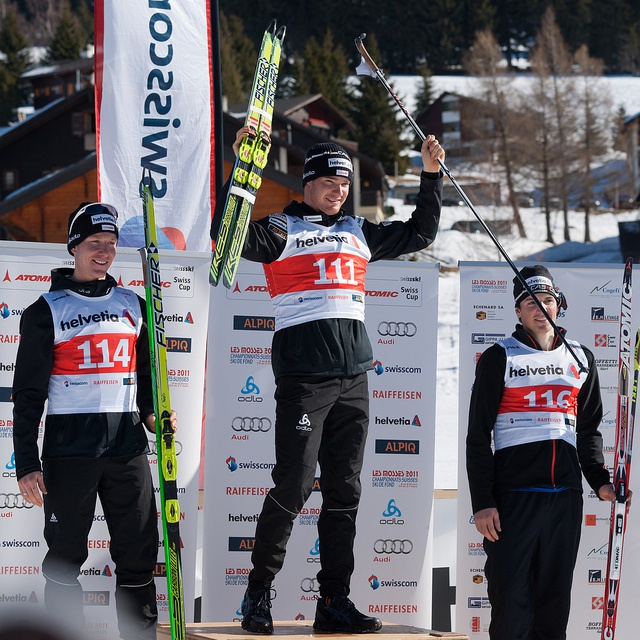Describe the objects in this image and their specific colors. I can see people in black, gray, lightgray, and darkgray tones, people in black, gray, darkgray, and lavender tones, people in black, darkgray, and lavender tones, skis in black, lightgray, gray, and khaki tones, and skis in black, olive, green, and darkgreen tones in this image. 